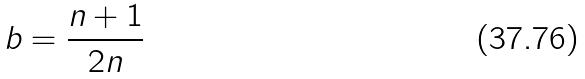<formula> <loc_0><loc_0><loc_500><loc_500>b = \frac { n + 1 } { 2 n }</formula> 